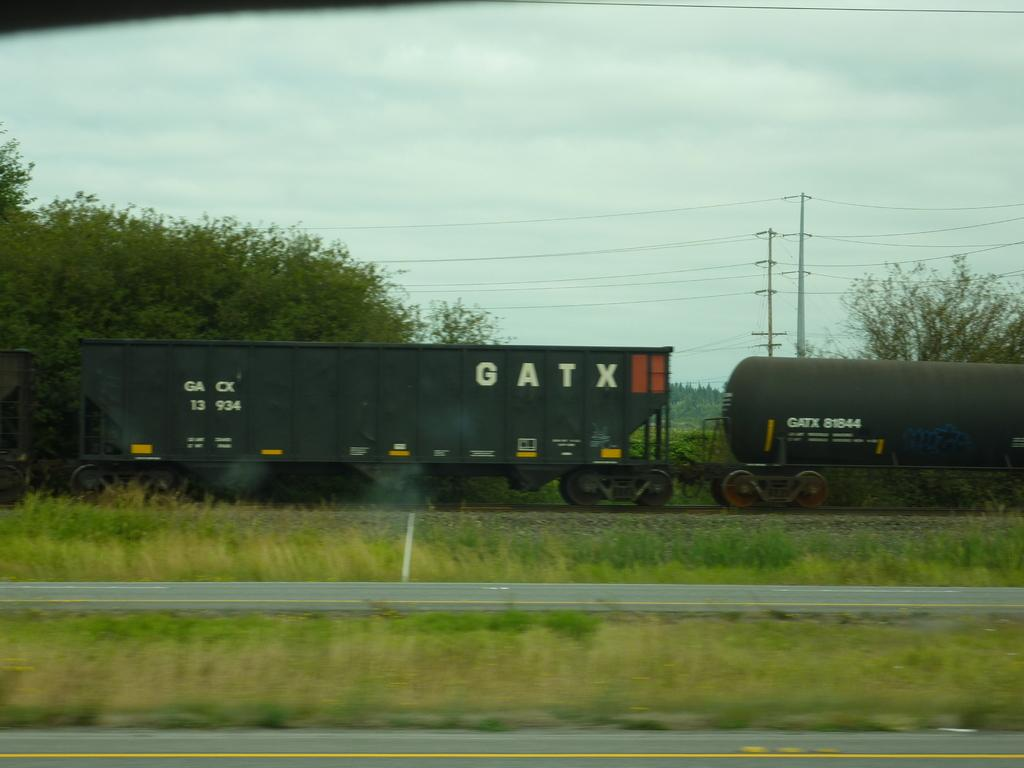What can be seen in the foreground of the image? There are roads and grassland in the foreground of the image. What is visible in the background of the image? There are trees, poles, a train, wires, and the sky in the background of the image. Can you describe the vegetation in the image? There are trees in the background of the image. What type of infrastructure is present in the image? There are poles and wires in the background of the image. What mode of transportation can be seen in the image? There is a train in the background of the image. What flavor of destruction can be seen in the image? There is no destruction present in the image, and therefore no flavor can be associated with it. What type of body is visible in the image? There is no body present in the image; it features roads, grassland, trees, poles, wires, a train, and the sky. 